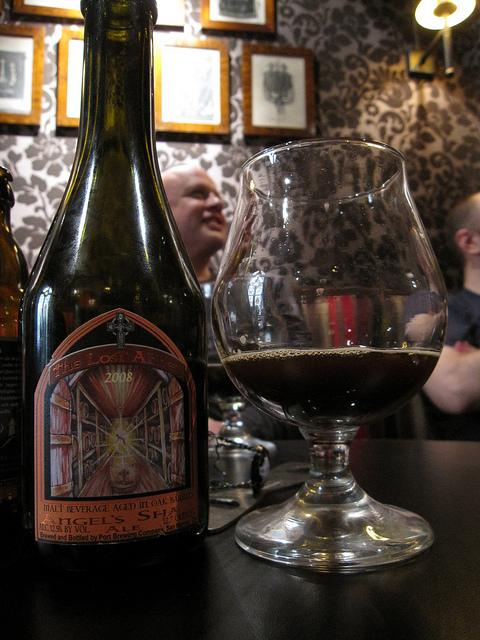What is in the glass? ale 